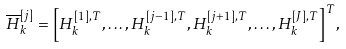<formula> <loc_0><loc_0><loc_500><loc_500>\overline { H } _ { k } ^ { [ j ] } = { \left [ { H } _ { k } ^ { [ 1 ] , T } , \dots , { H } _ { k } ^ { [ { j - 1 } ] , T } , { H } _ { k } ^ { [ { j + 1 } ] , T } , \dots , { H } _ { k } ^ { [ J ] , T } \right ] ^ { T } } ,</formula> 